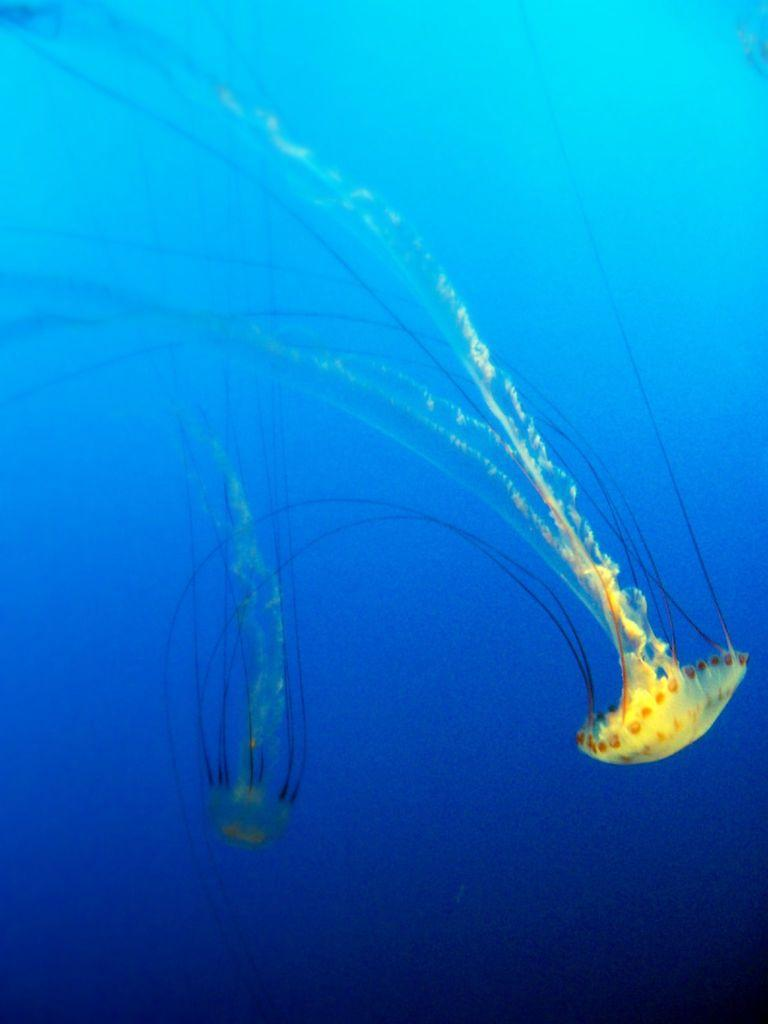What is the main subject of the image? There is a jellyfish in the image. Where is the jellyfish located? The jellyfish is in the water. What impulse does the jellyfish have in the image? There is no indication of any impulse or action taken by the jellyfish in the image; it is simply floating in the water. How does the jellyfish breathe in the image? Jellyfish do not breathe in the same way as humans or other animals; they obtain oxygen through diffusion across their body surface. However, there is no specific information about the jellyfish's breathing process in the image. 